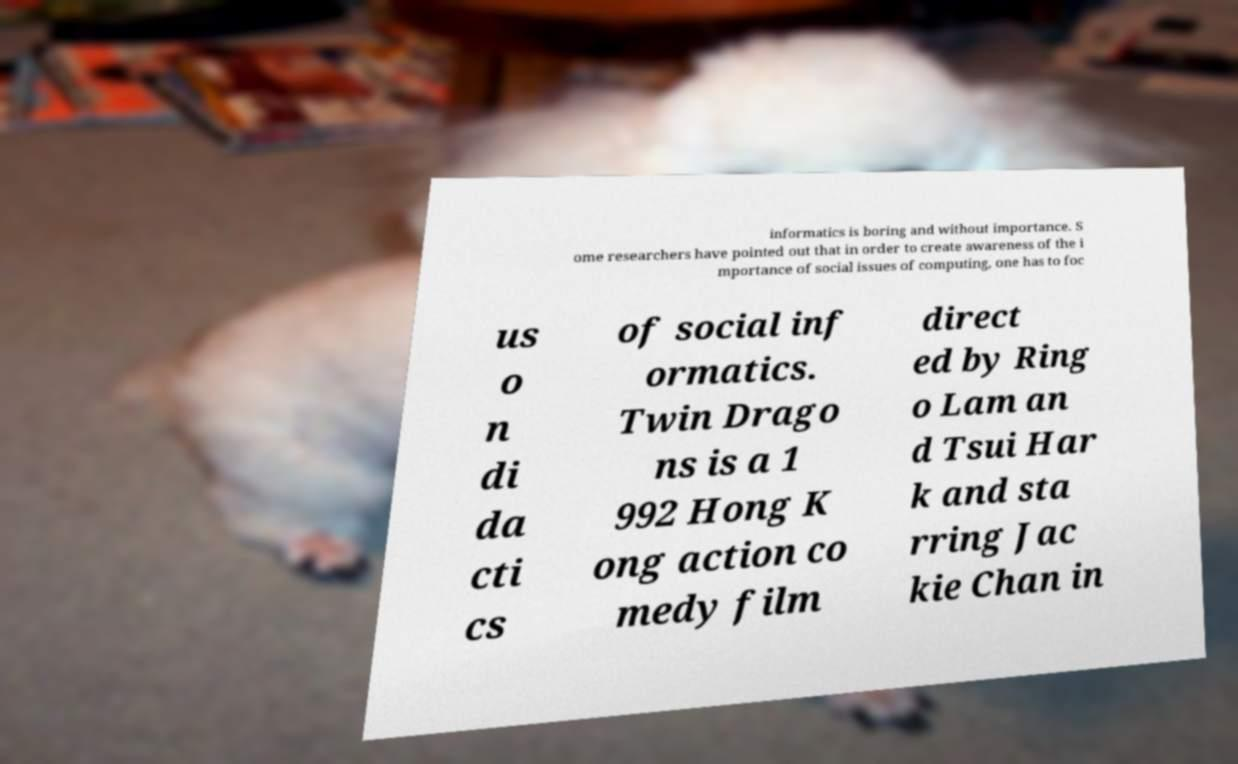Could you assist in decoding the text presented in this image and type it out clearly? informatics is boring and without importance. S ome researchers have pointed out that in order to create awareness of the i mportance of social issues of computing, one has to foc us o n di da cti cs of social inf ormatics. Twin Drago ns is a 1 992 Hong K ong action co medy film direct ed by Ring o Lam an d Tsui Har k and sta rring Jac kie Chan in 